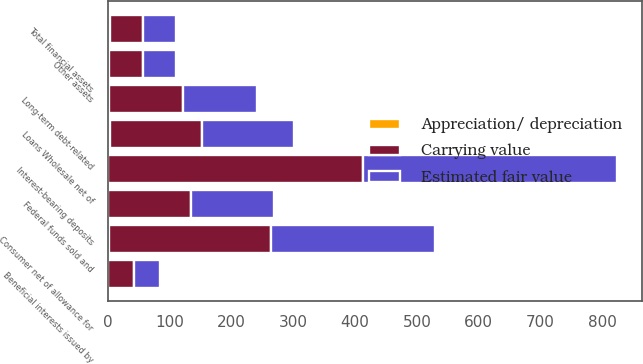<chart> <loc_0><loc_0><loc_500><loc_500><stacked_bar_chart><ecel><fcel>Federal funds sold and<fcel>Loans Wholesale net of<fcel>Consumer net of allowance for<fcel>Other assets<fcel>Total financial assets<fcel>Interest-bearing deposits<fcel>Beneficial interests issued by<fcel>Long-term debt-related<nl><fcel>Estimated fair value<fcel>134<fcel>147.7<fcel>264.4<fcel>53.4<fcel>54.05<fcel>411.9<fcel>42.2<fcel>119.9<nl><fcel>Carrying value<fcel>134.3<fcel>150.2<fcel>262.7<fcel>54.7<fcel>54.05<fcel>411.7<fcel>42.1<fcel>120.6<nl><fcel>Appreciation/ depreciation<fcel>0.3<fcel>2.5<fcel>1.7<fcel>1.3<fcel>2.4<fcel>0.2<fcel>0.1<fcel>0.7<nl></chart> 